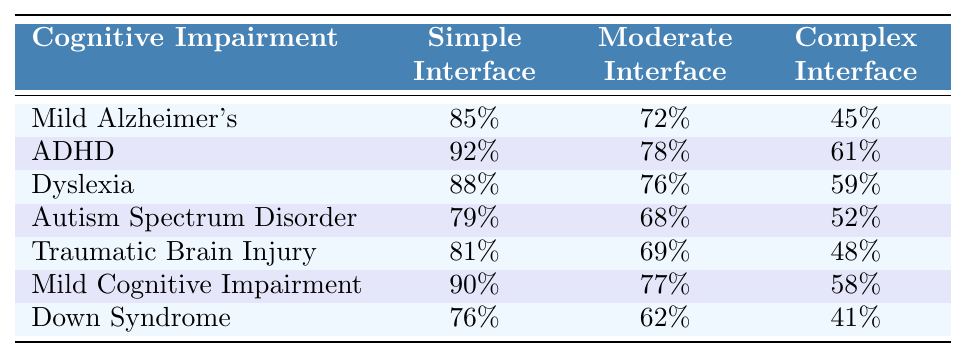What is the task completion rate for users with Mild Alzheimer's using a Simple Interface? From the table, the task completion rate for users with Mild Alzheimer's in the Simple Interface column is 85%.
Answer: 85% Which cognitive impairment has the highest task completion rate on the Complex Interface? By looking at the Complex Interface column, ADHD shows the highest value at 61%.
Answer: ADHD What is the average task completion rate for users with Dyslexia across all interfaces? The task completion rates for Dyslexia are 88% (Simple), 76% (Moderate), and 59% (Complex). The sum is 88 + 76 + 59 = 223. Dividing by 3 gives us an average of 223/3 = 74.33%.
Answer: 74.33% True or False: Users with Mild Cognitive Impairment have a higher completion rate in the Moderate Interface compared to those with Autism Spectrum Disorder. In the table, Mild Cognitive Impairment has a Moderate Interface rate of 77%, while Autism Spectrum Disorder has 68%, which means it is true.
Answer: True What is the combined task completion rate for all interfaces for users with Down Syndrome compared to those with Mild Alzheimer's? The completion rates for Down Syndrome are 76% (Simple), 62% (Moderate), and 41% (Complex), totaling 179%. For Mild Alzheimer's, the totals are 85% (Simple), 72% (Moderate), and 45% (Complex), totaling 202%. Since 179% is less than 202%, Down Syndrome has a lower combined rate.
Answer: Lower What is the difference in task completion rates between the Simple and Complex Interfaces for users with Traumatic Brain Injury? The completion rate for Simple Interface for Traumatic Brain Injury is 81%, while the Complex Interface is 48%. The difference is 81 - 48 = 33%.
Answer: 33% Which cognitive impairment type shows the least difference in task completion rates between the Simple and Moderate Interfaces? For each cognitive impairment type, we calculate the difference: Mild Alzheimer's (85 - 72 = 13), ADHD (92 - 78 = 14), Dyslexia (88 - 76 = 12), Autism Spectrum Disorder (79 - 68 = 11), Traumatic Brain Injury (81 - 69 = 12), Mild Cognitive Impairment (90 - 77 = 13), and Down Syndrome (76 - 62 = 14). Autism Spectrum Disorder shows the least difference of 11%.
Answer: Autism Spectrum Disorder Which cognitive impairments have a task completion rate of less than 50% in the Complex Interface? Looking at the Complex Interface column, only Down Syndrome (41%) and Autism Spectrum Disorder (52%) have rates below 50%. Down Syndrome is the only one that is below 50%.
Answer: Down Syndrome Which interface shows the highest variability in task completion rates across the different cognitive impairments? We calculate the variance for each interface: Simple Interface ranges from 76% (Down Syndrome) to 92% (ADHD) with a range of 16%. Moderate Interface's range is from 62% (Down Syndrome) to 78% (ADHD) with a range of 16%. Complex Interface ranges from 41% (Down Syndrome) to 61% (ADHD) with a range of 20%, which is the highest.
Answer: Complex Interface 